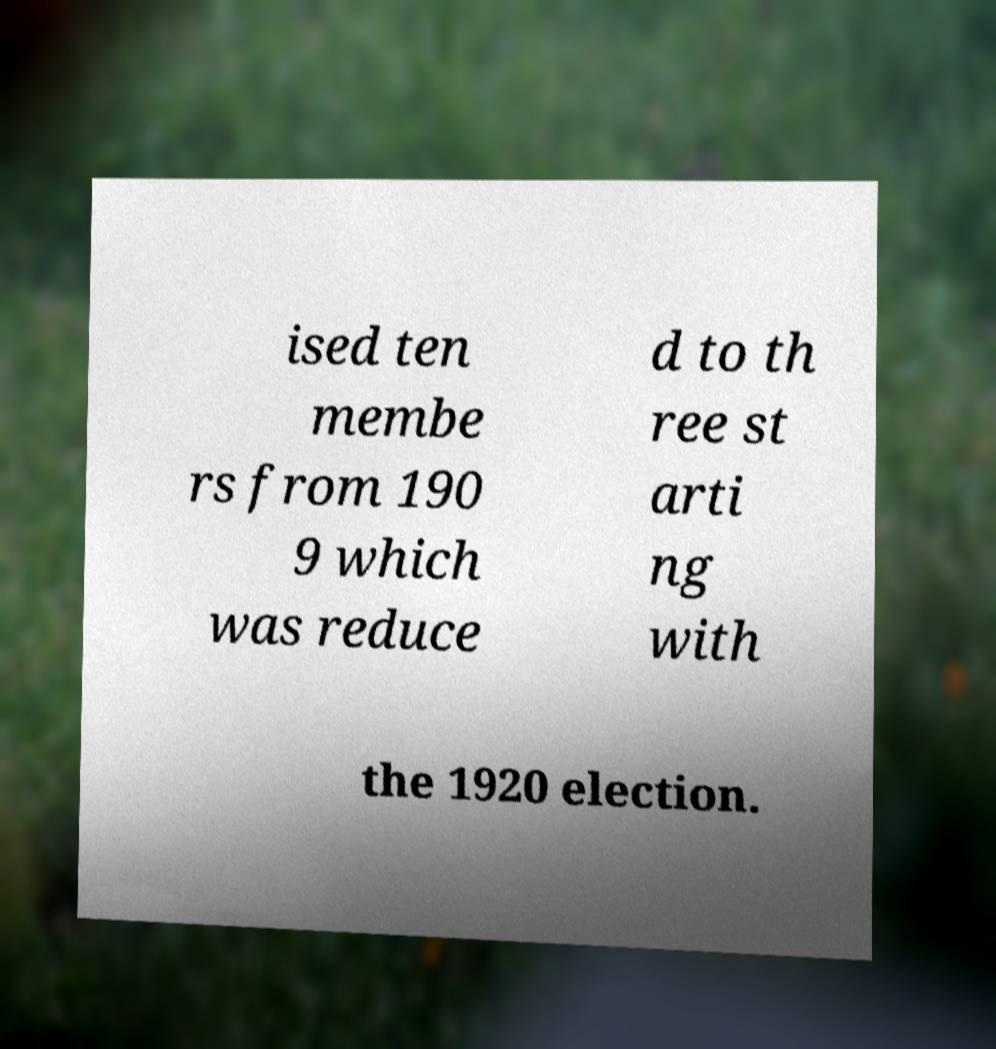Could you assist in decoding the text presented in this image and type it out clearly? ised ten membe rs from 190 9 which was reduce d to th ree st arti ng with the 1920 election. 